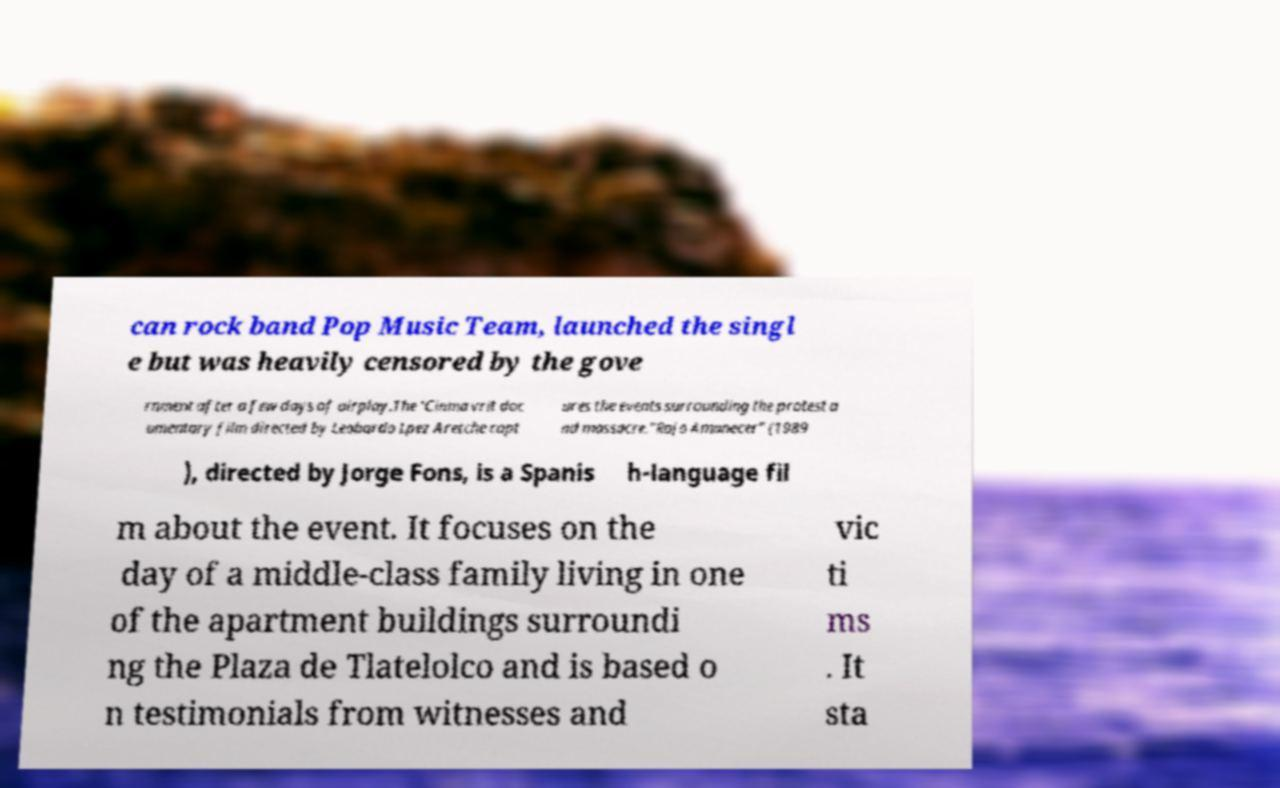Could you extract and type out the text from this image? can rock band Pop Music Team, launched the singl e but was heavily censored by the gove rnment after a few days of airplay.The 'Cinma vrit doc umentary film directed by Leobardo Lpez Aretche capt ures the events surrounding the protest a nd massacre."Rojo Amanecer" (1989 ), directed by Jorge Fons, is a Spanis h-language fil m about the event. It focuses on the day of a middle-class family living in one of the apartment buildings surroundi ng the Plaza de Tlatelolco and is based o n testimonials from witnesses and vic ti ms . It sta 